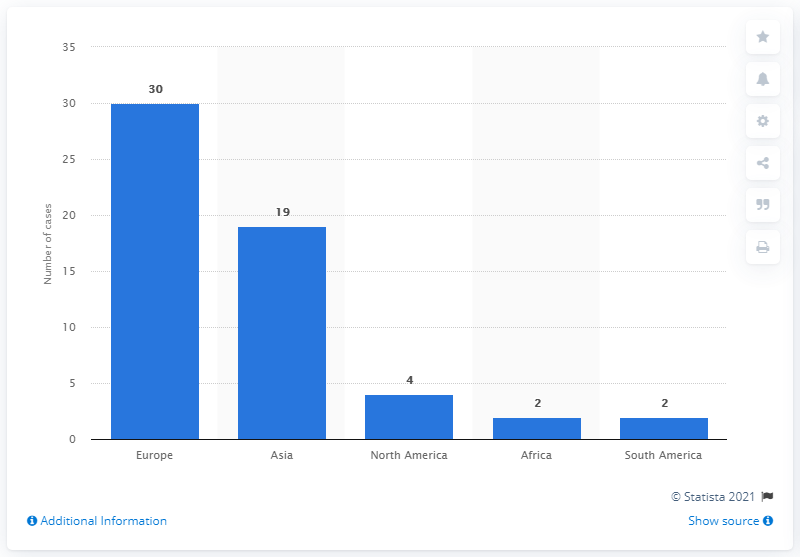List a handful of essential elements in this visual. Between 2000 and 2010, there were approximately 2 cases of match fixing in South America. 